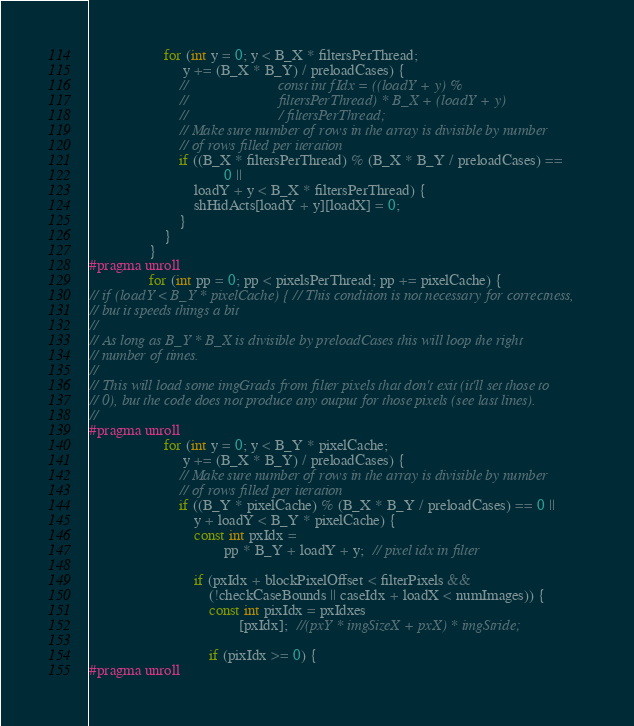Convert code to text. <code><loc_0><loc_0><loc_500><loc_500><_Cuda_>                    for (int y = 0; y < B_X * filtersPerThread;
                         y += (B_X * B_Y) / preloadCases) {
                        //                        const int fIdx = ((loadY + y) %
                        //                        filtersPerThread) * B_X + (loadY + y)
                        //                        / filtersPerThread;
                        // Make sure number of rows in the array is divisible by number
                        // of rows filled per iteration
                        if ((B_X * filtersPerThread) % (B_X * B_Y / preloadCases) ==
                                    0 ||
                            loadY + y < B_X * filtersPerThread) {
                            shHidActs[loadY + y][loadX] = 0;
                        }
                    }
                }
#pragma unroll
                for (int pp = 0; pp < pixelsPerThread; pp += pixelCache) {
// if (loadY < B_Y * pixelCache) { // This condition is not necessary for correctness,
// but it speeds things a bit
//
// As long as B_Y * B_X is divisible by preloadCases this will loop the right
// number of times.
//
// This will load some imgGrads from filter pixels that don't exit (it'll set those to
// 0), but the code does not produce any output for those pixels (see last lines).
//
#pragma unroll
                    for (int y = 0; y < B_Y * pixelCache;
                         y += (B_X * B_Y) / preloadCases) {
                        // Make sure number of rows in the array is divisible by number
                        // of rows filled per iteration
                        if ((B_Y * pixelCache) % (B_X * B_Y / preloadCases) == 0 ||
                            y + loadY < B_Y * pixelCache) {
                            const int pxIdx =
                                    pp * B_Y + loadY + y;  // pixel idx in filter

                            if (pxIdx + blockPixelOffset < filterPixels &&
                                (!checkCaseBounds || caseIdx + loadX < numImages)) {
                                const int pixIdx = pxIdxes
                                        [pxIdx];  //(pxY * imgSizeX + pxX) * imgStride;

                                if (pixIdx >= 0) {
#pragma unroll</code> 